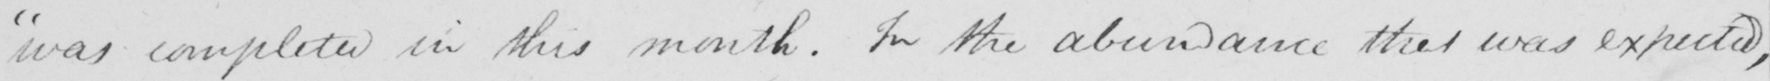Transcribe the text shown in this historical manuscript line. was completed in this month . In the abundance that was expected , 